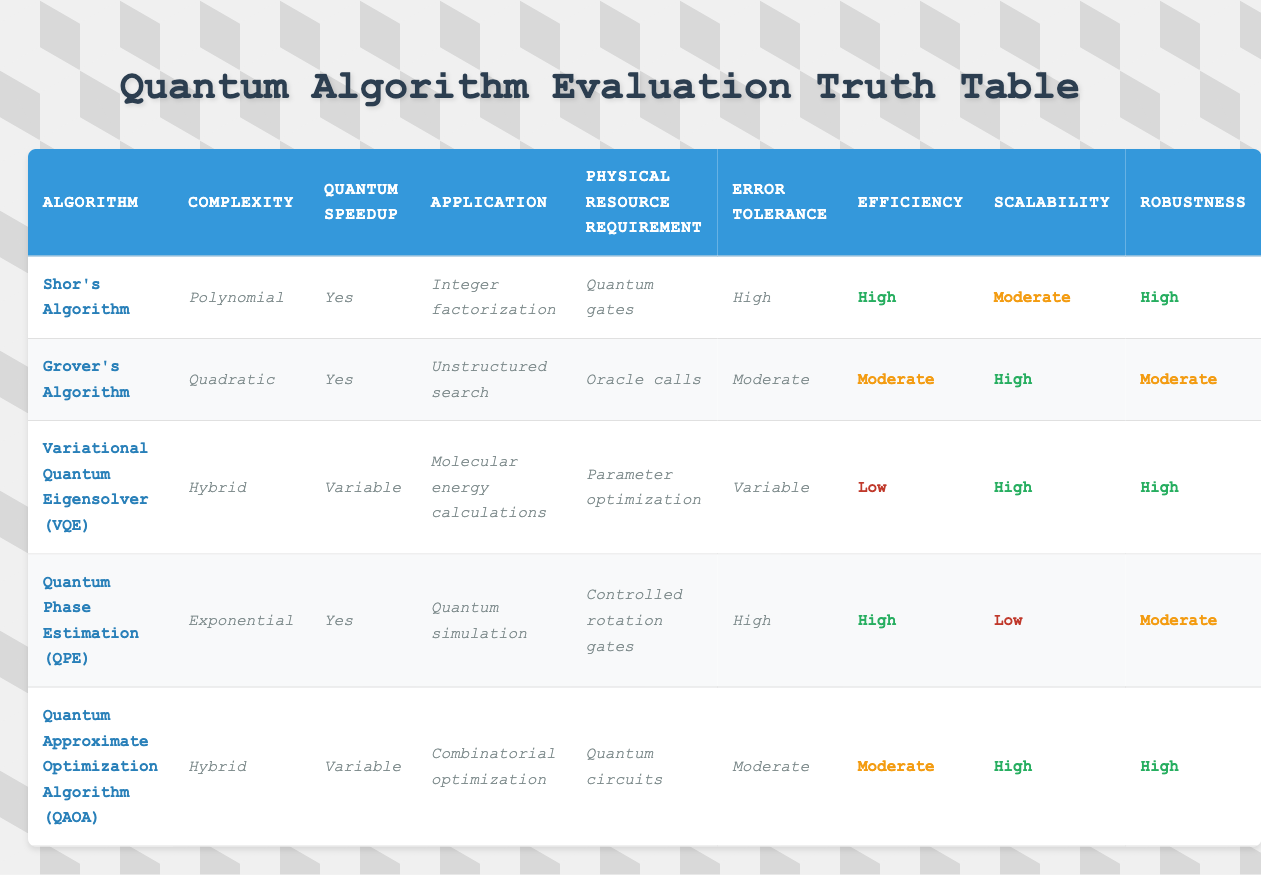What is the complexity of Shor's Algorithm? Shor's Algorithm is listed under the "Complexity" column in the table and shows "Polynomial" as its complexity.
Answer: Polynomial Which algorithm has the highest efficiency rating? In the table, the "Efficiency" column shows Shor's Algorithm and Quantum Phase Estimation (QPE) both rated as "High", but since they have the same rating, we could consider both in the answer.
Answer: Shor's Algorithm and Quantum Phase Estimation (QPE) Is there an algorithm with a "Variable" error tolerance? By scanning the "Error Tolerance" column, we see that the Variational Quantum Eigensolver (VQE) and Quantum Approximate Optimization Algorithm (QAOA) both show "Variable".
Answer: Yes What is the scalability rating of Grover's Algorithm? Looking at the "Scalability" column, Grover's Algorithm is rated as "High". This is directly answered by the visual information in the table.
Answer: High How many algorithms have "High" robustness? The robustness ratings of the algorithms are "High" for Shor's Algorithm, Variational Quantum Eigensolver (VQE), Quantum Phase Estimation (QPE), and Quantum Approximate Optimization Algorithm (QAOA). Counting these gives us four algorithms.
Answer: Four Which algorithm has a "Variable" quantum speedup? In the table, we look at the "Quantum Speedup" column where the Variational Quantum Eigensolver (VQE) and Quantum Approximate Optimization Algorithm (QAOA) are listed as having "Variable" quantum speedup.
Answer: Variational Quantum Eigensolver (VQE) and Quantum Approximate Optimization Algorithm (QAOA) What is the ratio of algorithms with "High" efficiency to those with "Low" efficiency? Shor's Algorithm and Quantum Phase Estimation (QPE) both have "High" efficiency ratings (2 algorithms), while Variational Quantum Eigensolver (VQE) is the only one rated as "Low". The ratio is therefore 2:1.
Answer: 2:1 Which algorithm is designed for integer factorization? Referring to the "Application" column, Shor's Algorithm is indicated as being designed for "Integer factorization".
Answer: Shor's Algorithm What is the physical resource requirement for Quantum Phase Estimation (QPE)? The "Physical Resource Requirement" column shows that Quantum Phase Estimation (QPE) requires "Controlled rotation gates". This information leads to the answer.
Answer: Controlled rotation gates 